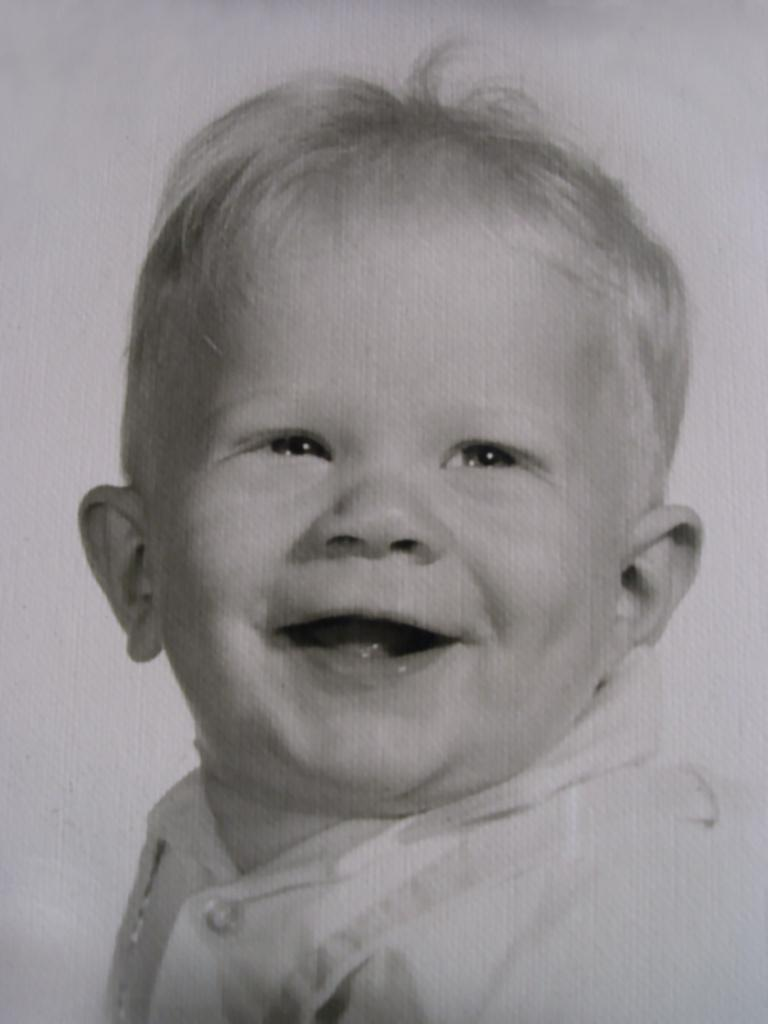What is the main subject of the image? There is a baby in the image. What is the baby doing in the image? The baby is smiling. What type of pain is the baby experiencing in the image? There is no indication of pain in the image; the baby is smiling. What kind of car is the baby driving in the image? There is no car present in the image; it features a baby. 